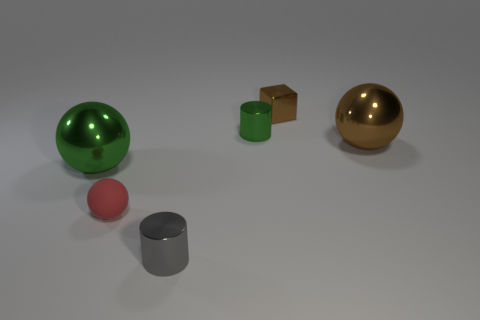Is the material of the brown thing that is in front of the brown shiny block the same as the tiny thing that is left of the tiny gray thing?
Give a very brief answer. No. How many brown shiny things have the same shape as the tiny rubber object?
Make the answer very short. 1. Are there more large metal objects to the left of the small metallic block than cyan metallic spheres?
Your answer should be compact. Yes. What is the shape of the small metal object in front of the metal sphere on the right side of the small cylinder behind the gray metallic thing?
Keep it short and to the point. Cylinder. Is the shape of the small metal thing that is in front of the tiny green thing the same as the green thing right of the matte thing?
Give a very brief answer. Yes. What number of blocks are either tiny green objects or big green metallic objects?
Provide a short and direct response. 0. Do the brown block and the small green thing have the same material?
Make the answer very short. Yes. How many other things are there of the same color as the metallic block?
Ensure brevity in your answer.  1. What is the shape of the small brown thing that is behind the gray cylinder?
Your answer should be very brief. Cube. How many things are brown spheres or tiny gray things?
Provide a succinct answer. 2. 